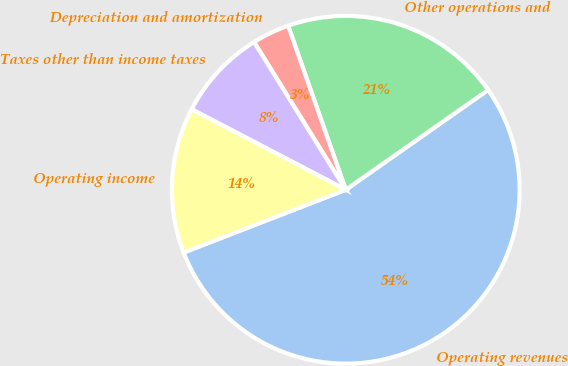Convert chart to OTSL. <chart><loc_0><loc_0><loc_500><loc_500><pie_chart><fcel>Operating revenues<fcel>Other operations and<fcel>Depreciation and amortization<fcel>Taxes other than income taxes<fcel>Operating income<nl><fcel>53.86%<fcel>20.65%<fcel>3.46%<fcel>8.5%<fcel>13.54%<nl></chart> 